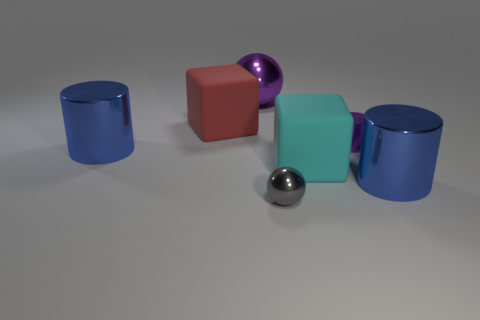How many blue cylinders must be subtracted to get 1 blue cylinders? 1 Add 2 cylinders. How many objects exist? 9 Subtract all cylinders. How many objects are left? 4 Add 2 large rubber blocks. How many large rubber blocks are left? 4 Add 4 blue metallic cylinders. How many blue metallic cylinders exist? 6 Subtract 0 yellow blocks. How many objects are left? 7 Subtract all brown things. Subtract all red matte blocks. How many objects are left? 6 